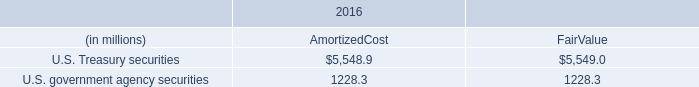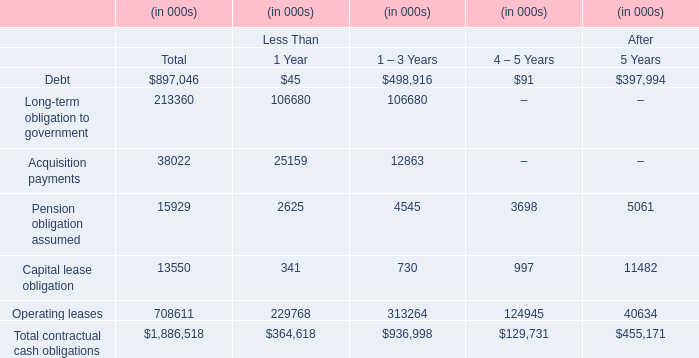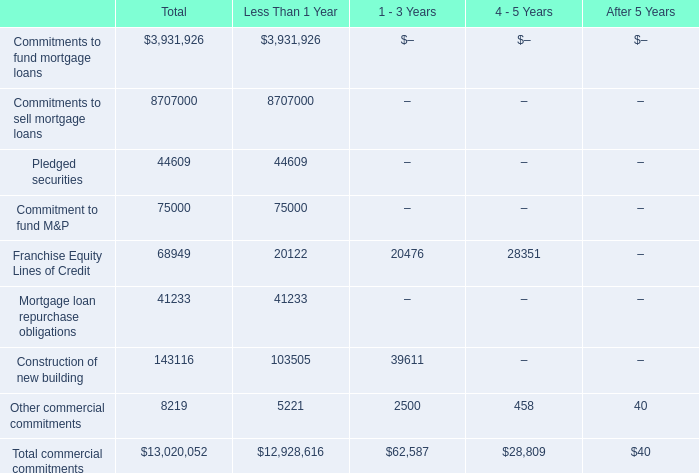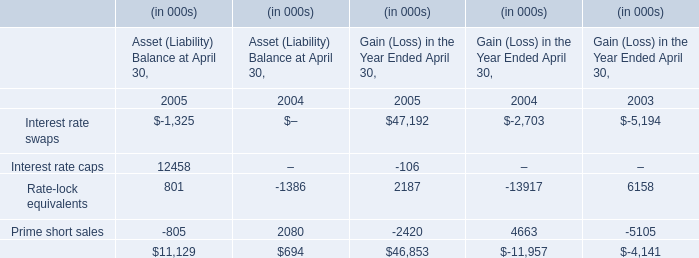In which section is Franchise Equity Lines of Credit smaller than Mortgage loan repurchase obligations? 
Answer: Less Than 1 Year. 